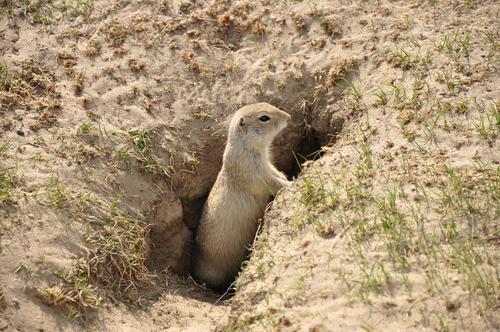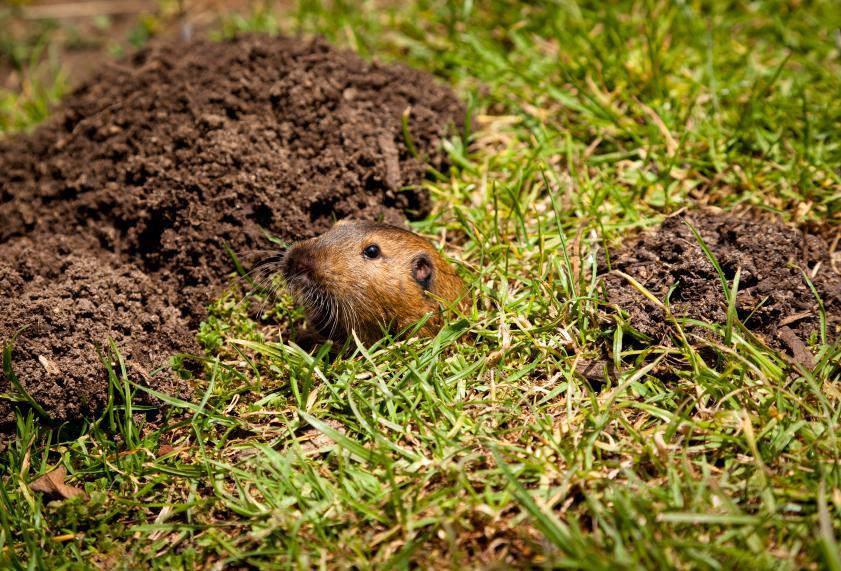The first image is the image on the left, the second image is the image on the right. Examine the images to the left and right. Is the description "A marmot is partly in a hole." accurate? Answer yes or no. Yes. The first image is the image on the left, the second image is the image on the right. Examine the images to the left and right. Is the description "The left and right image contains the same number of rodents walking on the grass." accurate? Answer yes or no. No. 